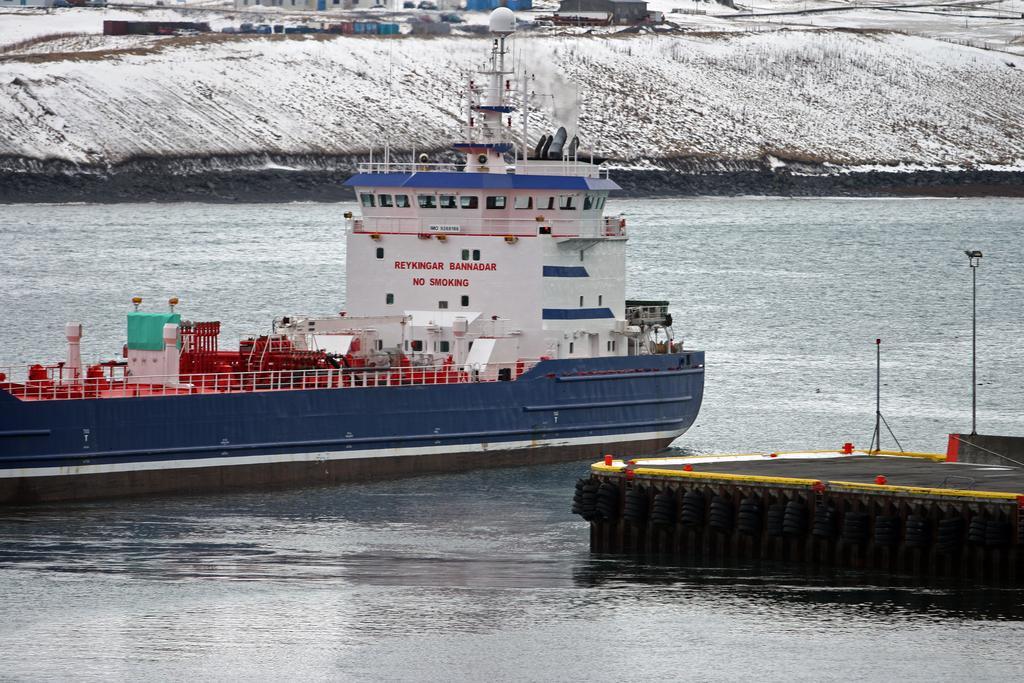How would you summarize this image in a sentence or two? In this picture we can see water at the bottom, there is a ship in the water, we can see snow in the background. 